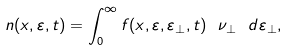Convert formula to latex. <formula><loc_0><loc_0><loc_500><loc_500>n ( x , \varepsilon , t ) = \int _ { 0 } ^ { \infty } f ( x , \varepsilon , \varepsilon _ { \perp } , t ) \ \nu _ { \perp } \ d \varepsilon _ { \perp } ,</formula> 